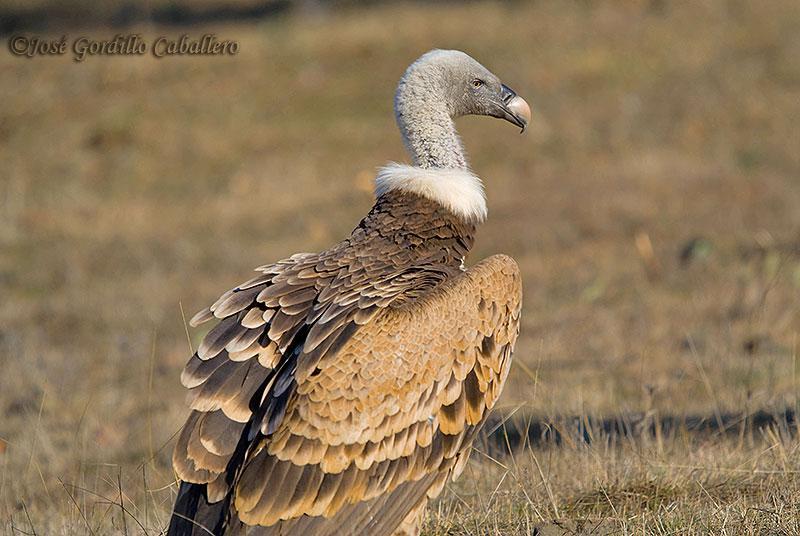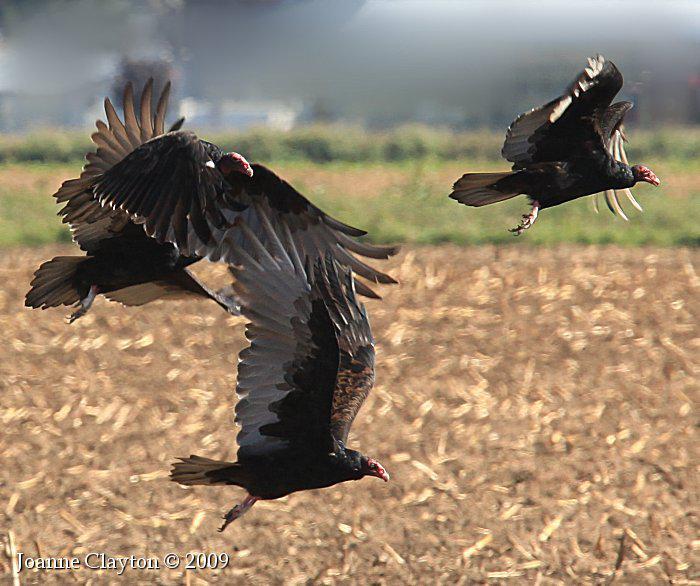The first image is the image on the left, the second image is the image on the right. For the images shown, is this caption "Right image shows a bird in the foreground with wings spread and off the ground." true? Answer yes or no. Yes. The first image is the image on the left, the second image is the image on the right. For the images shown, is this caption "One image in the pair includes vultures with a carcass." true? Answer yes or no. No. 